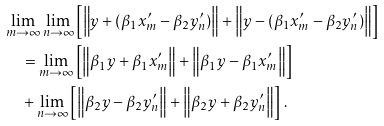Convert formula to latex. <formula><loc_0><loc_0><loc_500><loc_500>& \lim _ { m \to \infty } \lim _ { n \to \infty } \left [ \Big { \| } y + ( \beta _ { 1 } x ^ { \prime } _ { m } - \beta _ { 2 } y ^ { \prime } _ { n } ) \Big { \| } + \Big { \| } y - ( \beta _ { 1 } x ^ { \prime } _ { m } - \beta _ { 2 } y ^ { \prime } _ { n } ) \Big { \| } \right ] \\ & \quad = \lim _ { m \to \infty } \left [ \Big { \| } \beta _ { 1 } y + \beta _ { 1 } x ^ { \prime } _ { m } \Big { \| } + \Big { \| } \beta _ { 1 } y - \beta _ { 1 } x ^ { \prime } _ { m } \Big { \| } \right ] \\ & \quad + \lim _ { n \to \infty } \left [ \Big { \| } \beta _ { 2 } y - \beta _ { 2 } y ^ { \prime } _ { n } \Big { \| } + \Big { \| } \beta _ { 2 } y + \beta _ { 2 } y ^ { \prime } _ { n } \Big { \| } \right ] \, .</formula> 